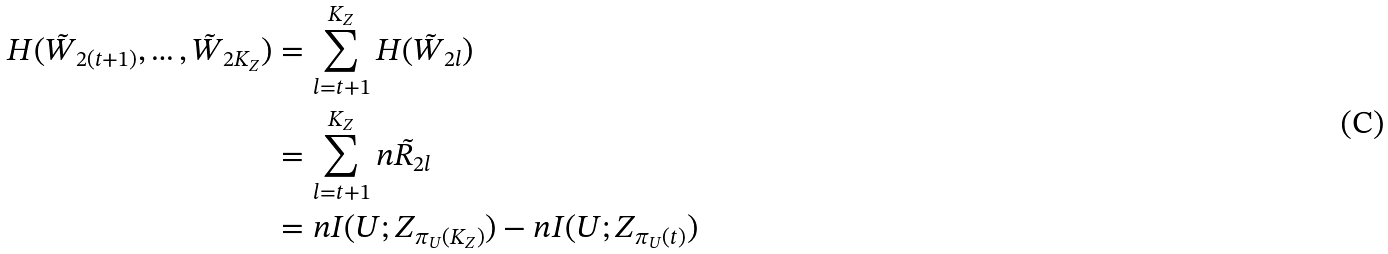<formula> <loc_0><loc_0><loc_500><loc_500>H ( \tilde { W } _ { 2 ( t + 1 ) } , \dots , \tilde { W } _ { 2 K _ { Z } } ) & = \sum _ { l = t + 1 } ^ { K _ { Z } } H ( \tilde { W } _ { 2 l } ) \\ & = \sum _ { l = t + 1 } ^ { K _ { Z } } n \tilde { R } _ { 2 l } \\ & = n I ( U ; Z _ { \pi _ { U } ( K _ { Z } ) } ) - n I ( U ; Z _ { \pi _ { U } ( t ) } )</formula> 